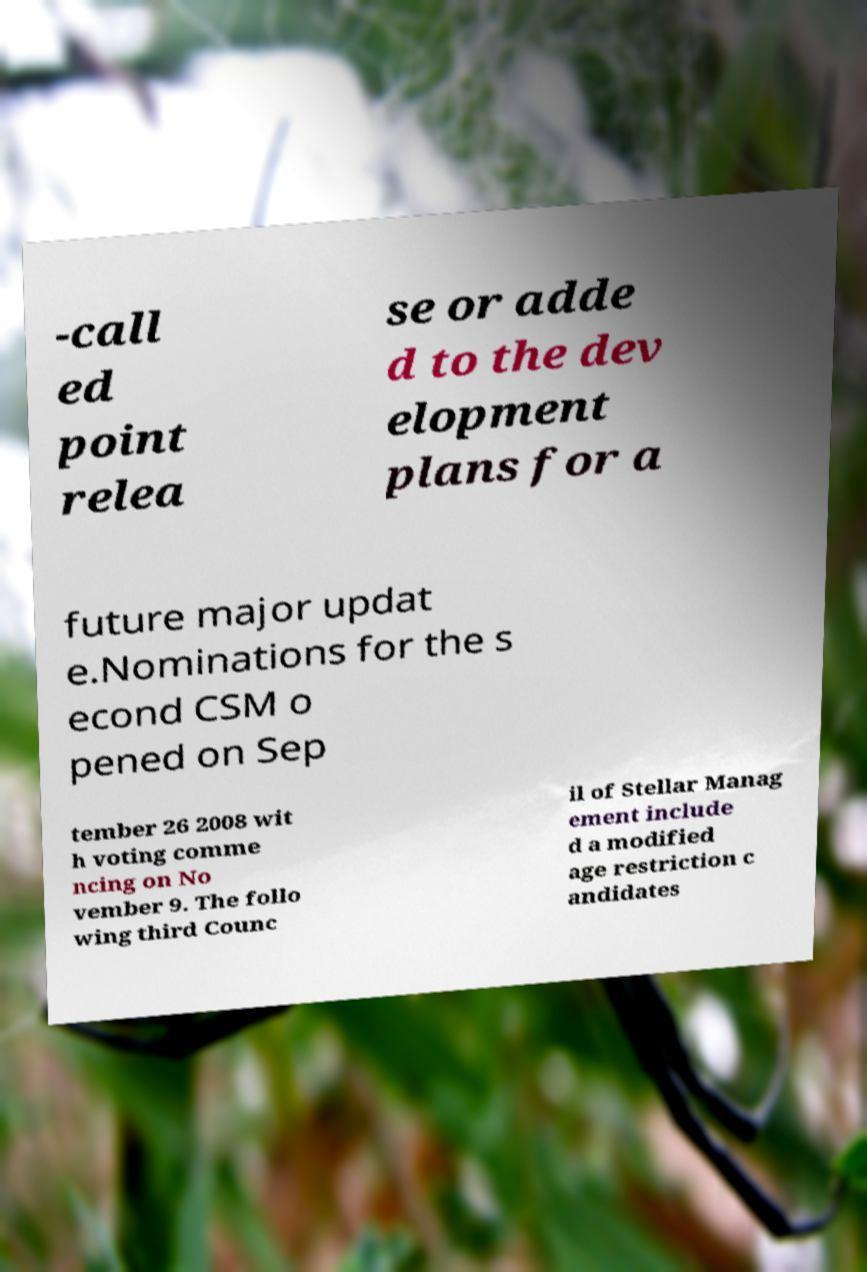Please identify and transcribe the text found in this image. -call ed point relea se or adde d to the dev elopment plans for a future major updat e.Nominations for the s econd CSM o pened on Sep tember 26 2008 wit h voting comme ncing on No vember 9. The follo wing third Counc il of Stellar Manag ement include d a modified age restriction c andidates 